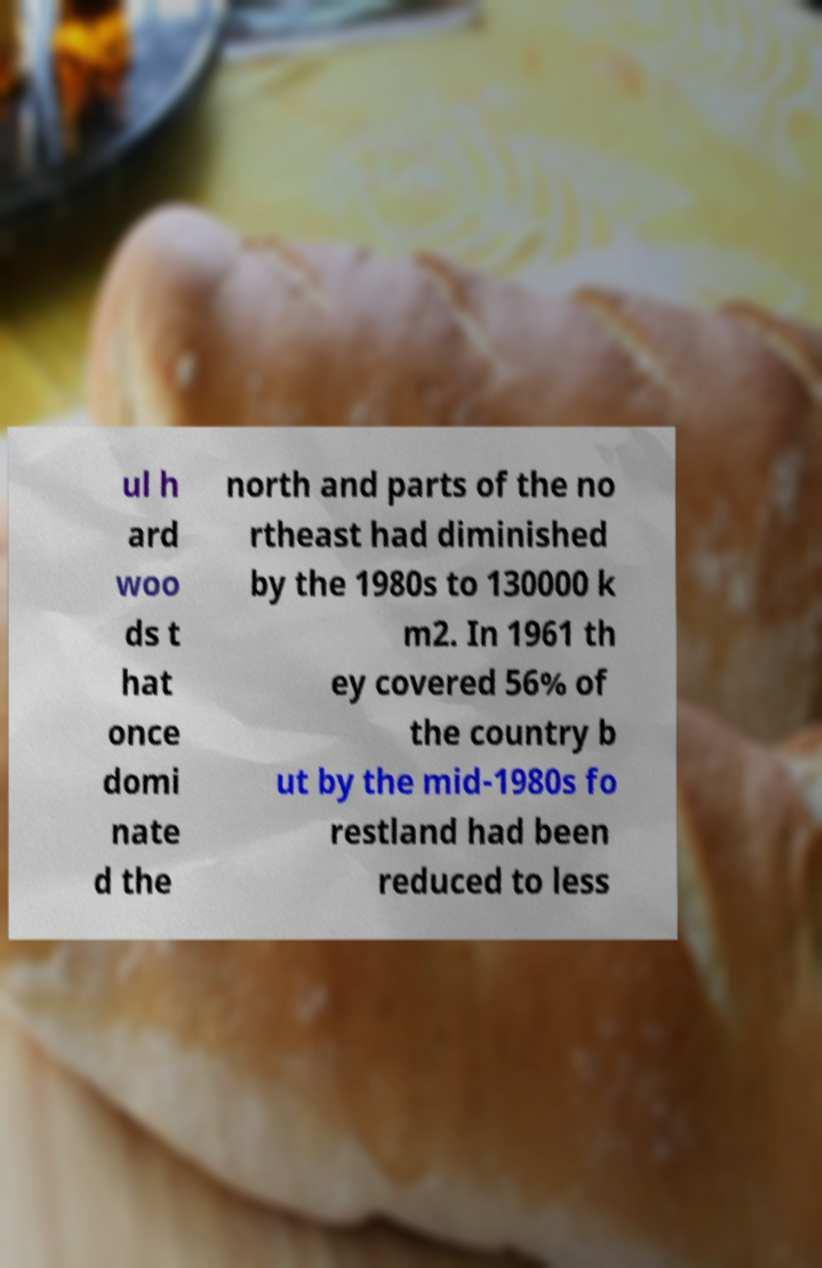Please identify and transcribe the text found in this image. ul h ard woo ds t hat once domi nate d the north and parts of the no rtheast had diminished by the 1980s to 130000 k m2. In 1961 th ey covered 56% of the country b ut by the mid-1980s fo restland had been reduced to less 